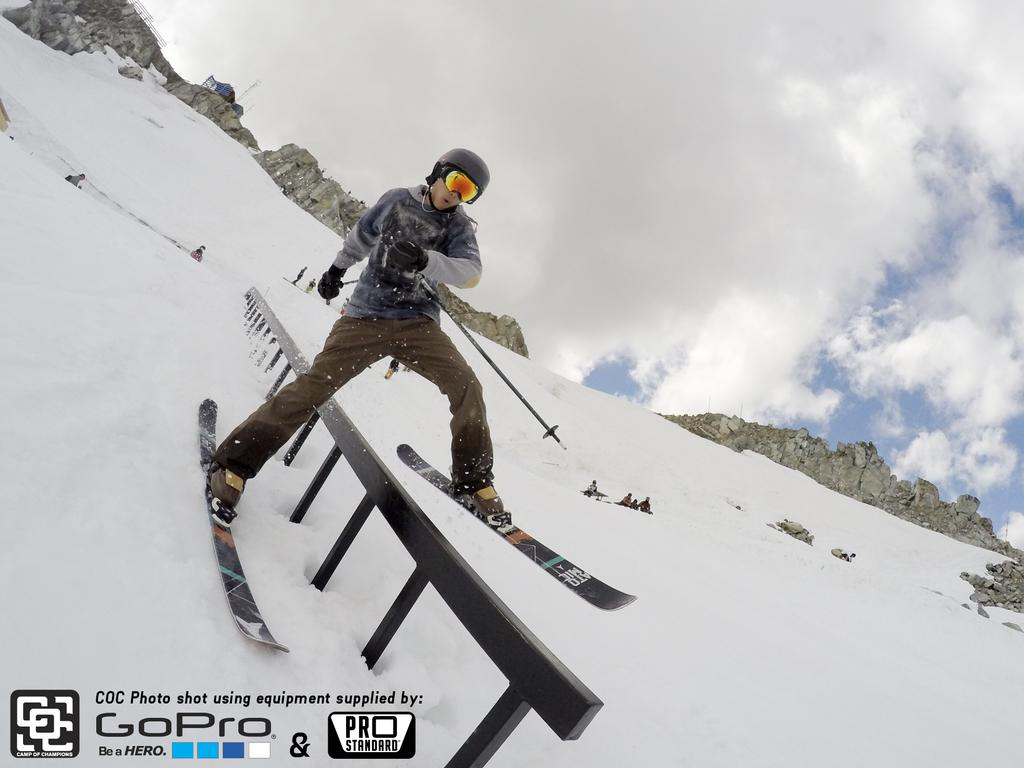What is the person in the image doing? The person is skating on the ice. What equipment is the person using for skating? The person has ski boards on his legs. Can you describe the background of the image? There are people visible in the background. What is the condition of the hill in the image? The hill is snowy. How would you describe the sky in the image? The sky is cloudy. What type of desk can be seen in the mouth of the person skating in the image? There is no desk present in the image, nor is there any indication that a person's mouth is visible. 